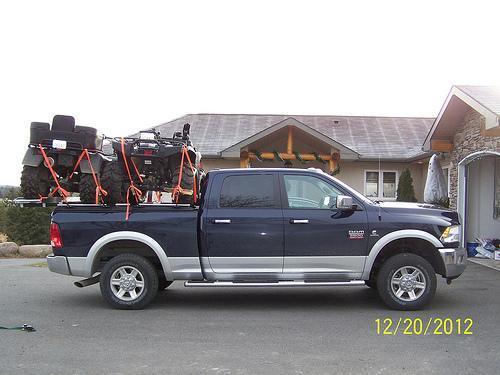How many trucks are in the photo?
Give a very brief answer. 1. 